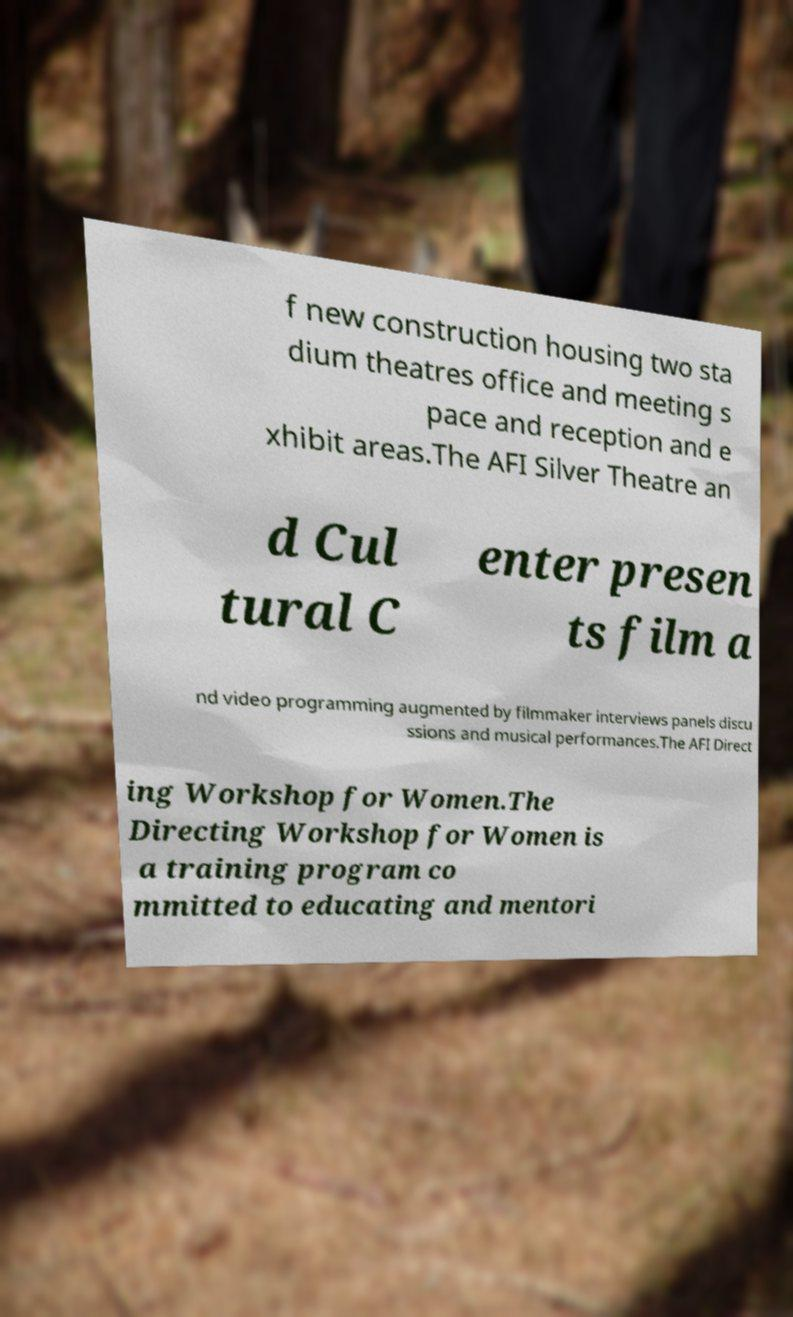Please identify and transcribe the text found in this image. f new construction housing two sta dium theatres office and meeting s pace and reception and e xhibit areas.The AFI Silver Theatre an d Cul tural C enter presen ts film a nd video programming augmented by filmmaker interviews panels discu ssions and musical performances.The AFI Direct ing Workshop for Women.The Directing Workshop for Women is a training program co mmitted to educating and mentori 